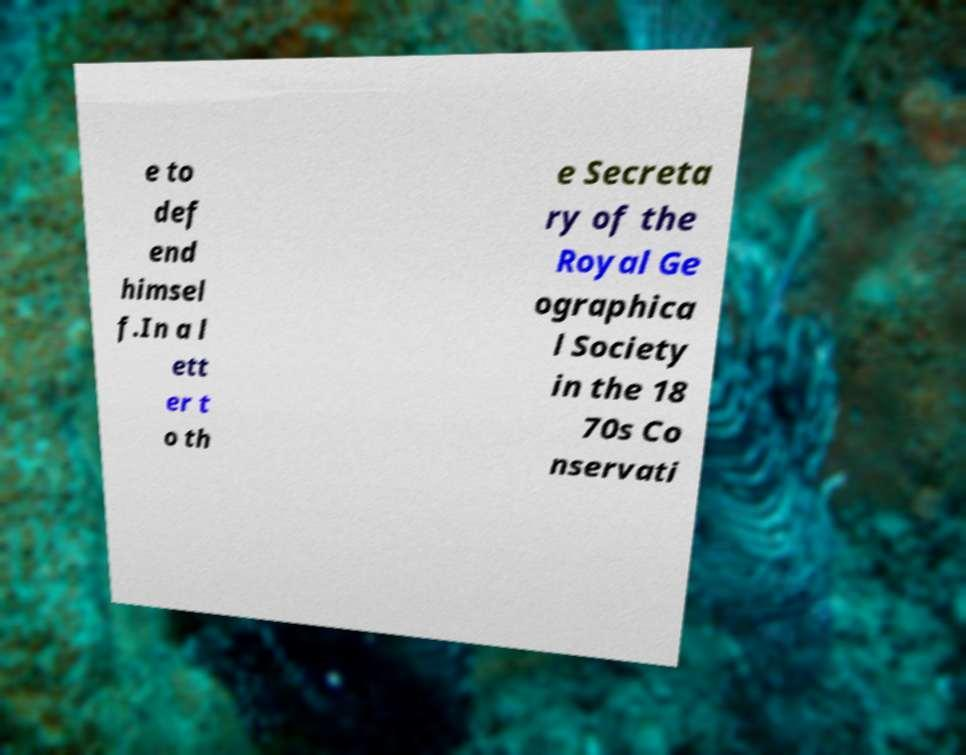Please read and relay the text visible in this image. What does it say? e to def end himsel f.In a l ett er t o th e Secreta ry of the Royal Ge ographica l Society in the 18 70s Co nservati 